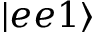Convert formula to latex. <formula><loc_0><loc_0><loc_500><loc_500>| e e 1 \rangle</formula> 